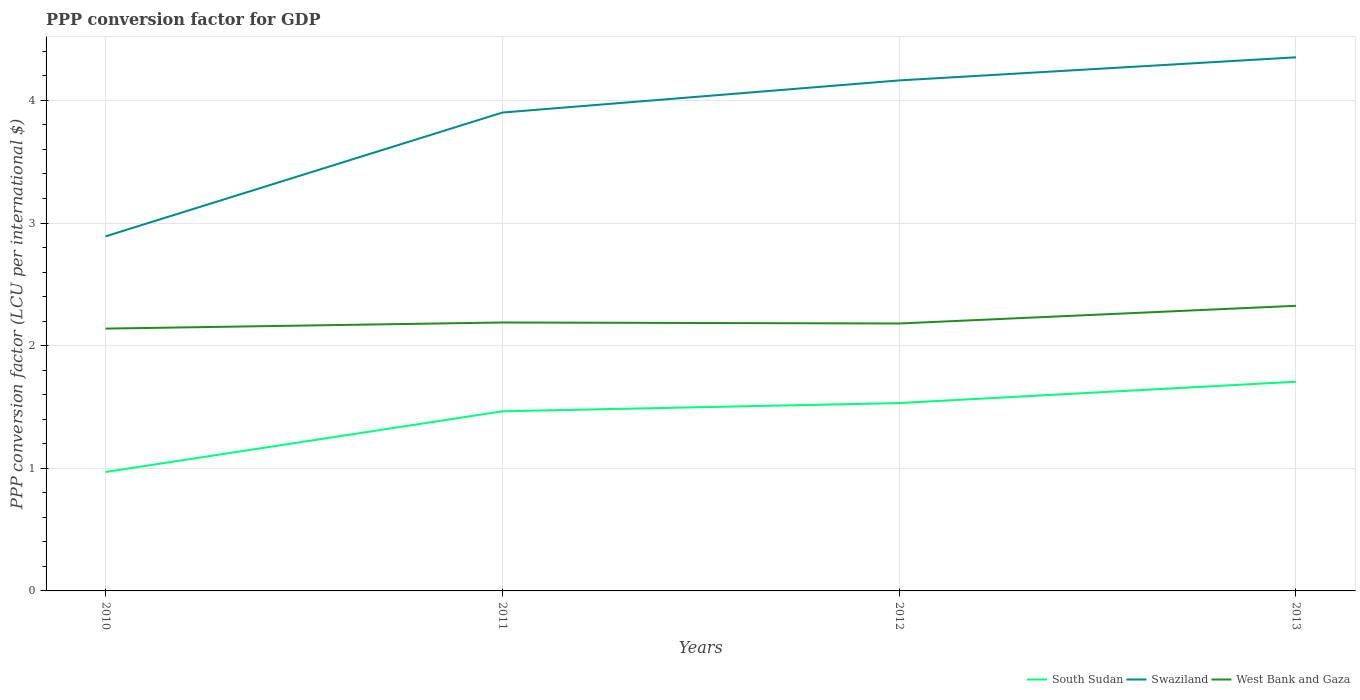How many different coloured lines are there?
Offer a very short reply. 3. Does the line corresponding to Swaziland intersect with the line corresponding to West Bank and Gaza?
Your answer should be very brief. No. Is the number of lines equal to the number of legend labels?
Provide a short and direct response. Yes. Across all years, what is the maximum PPP conversion factor for GDP in Swaziland?
Keep it short and to the point. 2.89. In which year was the PPP conversion factor for GDP in West Bank and Gaza maximum?
Your answer should be compact. 2010. What is the total PPP conversion factor for GDP in Swaziland in the graph?
Your response must be concise. -1.46. What is the difference between the highest and the second highest PPP conversion factor for GDP in South Sudan?
Ensure brevity in your answer.  0.74. Is the PPP conversion factor for GDP in West Bank and Gaza strictly greater than the PPP conversion factor for GDP in Swaziland over the years?
Make the answer very short. Yes. What is the difference between two consecutive major ticks on the Y-axis?
Ensure brevity in your answer.  1. Are the values on the major ticks of Y-axis written in scientific E-notation?
Offer a very short reply. No. Where does the legend appear in the graph?
Provide a short and direct response. Bottom right. How many legend labels are there?
Make the answer very short. 3. What is the title of the graph?
Make the answer very short. PPP conversion factor for GDP. Does "Micronesia" appear as one of the legend labels in the graph?
Offer a very short reply. No. What is the label or title of the Y-axis?
Keep it short and to the point. PPP conversion factor (LCU per international $). What is the PPP conversion factor (LCU per international $) of South Sudan in 2010?
Your answer should be compact. 0.97. What is the PPP conversion factor (LCU per international $) in Swaziland in 2010?
Offer a very short reply. 2.89. What is the PPP conversion factor (LCU per international $) of West Bank and Gaza in 2010?
Your response must be concise. 2.14. What is the PPP conversion factor (LCU per international $) of South Sudan in 2011?
Provide a succinct answer. 1.46. What is the PPP conversion factor (LCU per international $) of Swaziland in 2011?
Ensure brevity in your answer.  3.9. What is the PPP conversion factor (LCU per international $) of West Bank and Gaza in 2011?
Keep it short and to the point. 2.19. What is the PPP conversion factor (LCU per international $) of South Sudan in 2012?
Your response must be concise. 1.53. What is the PPP conversion factor (LCU per international $) in Swaziland in 2012?
Keep it short and to the point. 4.16. What is the PPP conversion factor (LCU per international $) in West Bank and Gaza in 2012?
Ensure brevity in your answer.  2.18. What is the PPP conversion factor (LCU per international $) of South Sudan in 2013?
Offer a very short reply. 1.71. What is the PPP conversion factor (LCU per international $) of Swaziland in 2013?
Keep it short and to the point. 4.35. What is the PPP conversion factor (LCU per international $) of West Bank and Gaza in 2013?
Your answer should be very brief. 2.32. Across all years, what is the maximum PPP conversion factor (LCU per international $) of South Sudan?
Offer a very short reply. 1.71. Across all years, what is the maximum PPP conversion factor (LCU per international $) in Swaziland?
Make the answer very short. 4.35. Across all years, what is the maximum PPP conversion factor (LCU per international $) of West Bank and Gaza?
Your answer should be compact. 2.32. Across all years, what is the minimum PPP conversion factor (LCU per international $) in South Sudan?
Offer a very short reply. 0.97. Across all years, what is the minimum PPP conversion factor (LCU per international $) of Swaziland?
Give a very brief answer. 2.89. Across all years, what is the minimum PPP conversion factor (LCU per international $) in West Bank and Gaza?
Offer a terse response. 2.14. What is the total PPP conversion factor (LCU per international $) in South Sudan in the graph?
Your answer should be very brief. 5.67. What is the total PPP conversion factor (LCU per international $) of Swaziland in the graph?
Offer a very short reply. 15.31. What is the total PPP conversion factor (LCU per international $) of West Bank and Gaza in the graph?
Provide a short and direct response. 8.83. What is the difference between the PPP conversion factor (LCU per international $) in South Sudan in 2010 and that in 2011?
Your answer should be very brief. -0.49. What is the difference between the PPP conversion factor (LCU per international $) in Swaziland in 2010 and that in 2011?
Offer a very short reply. -1.01. What is the difference between the PPP conversion factor (LCU per international $) in South Sudan in 2010 and that in 2012?
Your response must be concise. -0.56. What is the difference between the PPP conversion factor (LCU per international $) in Swaziland in 2010 and that in 2012?
Your answer should be very brief. -1.27. What is the difference between the PPP conversion factor (LCU per international $) of West Bank and Gaza in 2010 and that in 2012?
Make the answer very short. -0.04. What is the difference between the PPP conversion factor (LCU per international $) in South Sudan in 2010 and that in 2013?
Your answer should be compact. -0.74. What is the difference between the PPP conversion factor (LCU per international $) in Swaziland in 2010 and that in 2013?
Provide a succinct answer. -1.46. What is the difference between the PPP conversion factor (LCU per international $) of West Bank and Gaza in 2010 and that in 2013?
Offer a very short reply. -0.19. What is the difference between the PPP conversion factor (LCU per international $) in South Sudan in 2011 and that in 2012?
Provide a short and direct response. -0.07. What is the difference between the PPP conversion factor (LCU per international $) in Swaziland in 2011 and that in 2012?
Your answer should be compact. -0.26. What is the difference between the PPP conversion factor (LCU per international $) in West Bank and Gaza in 2011 and that in 2012?
Provide a succinct answer. 0.01. What is the difference between the PPP conversion factor (LCU per international $) of South Sudan in 2011 and that in 2013?
Provide a succinct answer. -0.24. What is the difference between the PPP conversion factor (LCU per international $) in Swaziland in 2011 and that in 2013?
Offer a very short reply. -0.45. What is the difference between the PPP conversion factor (LCU per international $) in West Bank and Gaza in 2011 and that in 2013?
Your answer should be very brief. -0.14. What is the difference between the PPP conversion factor (LCU per international $) of South Sudan in 2012 and that in 2013?
Your answer should be very brief. -0.17. What is the difference between the PPP conversion factor (LCU per international $) in Swaziland in 2012 and that in 2013?
Make the answer very short. -0.19. What is the difference between the PPP conversion factor (LCU per international $) in West Bank and Gaza in 2012 and that in 2013?
Your answer should be very brief. -0.14. What is the difference between the PPP conversion factor (LCU per international $) of South Sudan in 2010 and the PPP conversion factor (LCU per international $) of Swaziland in 2011?
Offer a terse response. -2.93. What is the difference between the PPP conversion factor (LCU per international $) of South Sudan in 2010 and the PPP conversion factor (LCU per international $) of West Bank and Gaza in 2011?
Provide a succinct answer. -1.22. What is the difference between the PPP conversion factor (LCU per international $) of Swaziland in 2010 and the PPP conversion factor (LCU per international $) of West Bank and Gaza in 2011?
Your answer should be compact. 0.7. What is the difference between the PPP conversion factor (LCU per international $) in South Sudan in 2010 and the PPP conversion factor (LCU per international $) in Swaziland in 2012?
Keep it short and to the point. -3.19. What is the difference between the PPP conversion factor (LCU per international $) of South Sudan in 2010 and the PPP conversion factor (LCU per international $) of West Bank and Gaza in 2012?
Offer a very short reply. -1.21. What is the difference between the PPP conversion factor (LCU per international $) in Swaziland in 2010 and the PPP conversion factor (LCU per international $) in West Bank and Gaza in 2012?
Provide a short and direct response. 0.71. What is the difference between the PPP conversion factor (LCU per international $) in South Sudan in 2010 and the PPP conversion factor (LCU per international $) in Swaziland in 2013?
Keep it short and to the point. -3.38. What is the difference between the PPP conversion factor (LCU per international $) in South Sudan in 2010 and the PPP conversion factor (LCU per international $) in West Bank and Gaza in 2013?
Offer a very short reply. -1.36. What is the difference between the PPP conversion factor (LCU per international $) in Swaziland in 2010 and the PPP conversion factor (LCU per international $) in West Bank and Gaza in 2013?
Provide a succinct answer. 0.57. What is the difference between the PPP conversion factor (LCU per international $) of South Sudan in 2011 and the PPP conversion factor (LCU per international $) of Swaziland in 2012?
Your answer should be compact. -2.7. What is the difference between the PPP conversion factor (LCU per international $) in South Sudan in 2011 and the PPP conversion factor (LCU per international $) in West Bank and Gaza in 2012?
Make the answer very short. -0.72. What is the difference between the PPP conversion factor (LCU per international $) in Swaziland in 2011 and the PPP conversion factor (LCU per international $) in West Bank and Gaza in 2012?
Give a very brief answer. 1.72. What is the difference between the PPP conversion factor (LCU per international $) in South Sudan in 2011 and the PPP conversion factor (LCU per international $) in Swaziland in 2013?
Ensure brevity in your answer.  -2.89. What is the difference between the PPP conversion factor (LCU per international $) in South Sudan in 2011 and the PPP conversion factor (LCU per international $) in West Bank and Gaza in 2013?
Offer a terse response. -0.86. What is the difference between the PPP conversion factor (LCU per international $) in Swaziland in 2011 and the PPP conversion factor (LCU per international $) in West Bank and Gaza in 2013?
Your answer should be compact. 1.58. What is the difference between the PPP conversion factor (LCU per international $) in South Sudan in 2012 and the PPP conversion factor (LCU per international $) in Swaziland in 2013?
Ensure brevity in your answer.  -2.82. What is the difference between the PPP conversion factor (LCU per international $) in South Sudan in 2012 and the PPP conversion factor (LCU per international $) in West Bank and Gaza in 2013?
Ensure brevity in your answer.  -0.79. What is the difference between the PPP conversion factor (LCU per international $) in Swaziland in 2012 and the PPP conversion factor (LCU per international $) in West Bank and Gaza in 2013?
Your response must be concise. 1.84. What is the average PPP conversion factor (LCU per international $) of South Sudan per year?
Make the answer very short. 1.42. What is the average PPP conversion factor (LCU per international $) of Swaziland per year?
Provide a succinct answer. 3.83. What is the average PPP conversion factor (LCU per international $) in West Bank and Gaza per year?
Give a very brief answer. 2.21. In the year 2010, what is the difference between the PPP conversion factor (LCU per international $) in South Sudan and PPP conversion factor (LCU per international $) in Swaziland?
Your response must be concise. -1.92. In the year 2010, what is the difference between the PPP conversion factor (LCU per international $) in South Sudan and PPP conversion factor (LCU per international $) in West Bank and Gaza?
Offer a terse response. -1.17. In the year 2010, what is the difference between the PPP conversion factor (LCU per international $) in Swaziland and PPP conversion factor (LCU per international $) in West Bank and Gaza?
Make the answer very short. 0.75. In the year 2011, what is the difference between the PPP conversion factor (LCU per international $) in South Sudan and PPP conversion factor (LCU per international $) in Swaziland?
Give a very brief answer. -2.44. In the year 2011, what is the difference between the PPP conversion factor (LCU per international $) in South Sudan and PPP conversion factor (LCU per international $) in West Bank and Gaza?
Your answer should be very brief. -0.72. In the year 2011, what is the difference between the PPP conversion factor (LCU per international $) in Swaziland and PPP conversion factor (LCU per international $) in West Bank and Gaza?
Your answer should be compact. 1.71. In the year 2012, what is the difference between the PPP conversion factor (LCU per international $) of South Sudan and PPP conversion factor (LCU per international $) of Swaziland?
Provide a succinct answer. -2.63. In the year 2012, what is the difference between the PPP conversion factor (LCU per international $) in South Sudan and PPP conversion factor (LCU per international $) in West Bank and Gaza?
Ensure brevity in your answer.  -0.65. In the year 2012, what is the difference between the PPP conversion factor (LCU per international $) of Swaziland and PPP conversion factor (LCU per international $) of West Bank and Gaza?
Provide a succinct answer. 1.98. In the year 2013, what is the difference between the PPP conversion factor (LCU per international $) of South Sudan and PPP conversion factor (LCU per international $) of Swaziland?
Offer a very short reply. -2.65. In the year 2013, what is the difference between the PPP conversion factor (LCU per international $) of South Sudan and PPP conversion factor (LCU per international $) of West Bank and Gaza?
Your answer should be compact. -0.62. In the year 2013, what is the difference between the PPP conversion factor (LCU per international $) of Swaziland and PPP conversion factor (LCU per international $) of West Bank and Gaza?
Provide a succinct answer. 2.03. What is the ratio of the PPP conversion factor (LCU per international $) of South Sudan in 2010 to that in 2011?
Your answer should be compact. 0.66. What is the ratio of the PPP conversion factor (LCU per international $) in Swaziland in 2010 to that in 2011?
Provide a short and direct response. 0.74. What is the ratio of the PPP conversion factor (LCU per international $) of West Bank and Gaza in 2010 to that in 2011?
Provide a succinct answer. 0.98. What is the ratio of the PPP conversion factor (LCU per international $) of South Sudan in 2010 to that in 2012?
Your answer should be compact. 0.63. What is the ratio of the PPP conversion factor (LCU per international $) of Swaziland in 2010 to that in 2012?
Offer a terse response. 0.69. What is the ratio of the PPP conversion factor (LCU per international $) in West Bank and Gaza in 2010 to that in 2012?
Provide a short and direct response. 0.98. What is the ratio of the PPP conversion factor (LCU per international $) of South Sudan in 2010 to that in 2013?
Your answer should be very brief. 0.57. What is the ratio of the PPP conversion factor (LCU per international $) of Swaziland in 2010 to that in 2013?
Ensure brevity in your answer.  0.66. What is the ratio of the PPP conversion factor (LCU per international $) of West Bank and Gaza in 2010 to that in 2013?
Offer a very short reply. 0.92. What is the ratio of the PPP conversion factor (LCU per international $) in South Sudan in 2011 to that in 2012?
Provide a succinct answer. 0.96. What is the ratio of the PPP conversion factor (LCU per international $) in Swaziland in 2011 to that in 2012?
Your answer should be compact. 0.94. What is the ratio of the PPP conversion factor (LCU per international $) in West Bank and Gaza in 2011 to that in 2012?
Offer a very short reply. 1. What is the ratio of the PPP conversion factor (LCU per international $) of South Sudan in 2011 to that in 2013?
Ensure brevity in your answer.  0.86. What is the ratio of the PPP conversion factor (LCU per international $) of Swaziland in 2011 to that in 2013?
Provide a succinct answer. 0.9. What is the ratio of the PPP conversion factor (LCU per international $) in West Bank and Gaza in 2011 to that in 2013?
Your answer should be compact. 0.94. What is the ratio of the PPP conversion factor (LCU per international $) in South Sudan in 2012 to that in 2013?
Keep it short and to the point. 0.9. What is the ratio of the PPP conversion factor (LCU per international $) in Swaziland in 2012 to that in 2013?
Provide a short and direct response. 0.96. What is the ratio of the PPP conversion factor (LCU per international $) of West Bank and Gaza in 2012 to that in 2013?
Offer a very short reply. 0.94. What is the difference between the highest and the second highest PPP conversion factor (LCU per international $) of South Sudan?
Ensure brevity in your answer.  0.17. What is the difference between the highest and the second highest PPP conversion factor (LCU per international $) in Swaziland?
Your response must be concise. 0.19. What is the difference between the highest and the second highest PPP conversion factor (LCU per international $) in West Bank and Gaza?
Provide a short and direct response. 0.14. What is the difference between the highest and the lowest PPP conversion factor (LCU per international $) in South Sudan?
Make the answer very short. 0.74. What is the difference between the highest and the lowest PPP conversion factor (LCU per international $) in Swaziland?
Offer a terse response. 1.46. What is the difference between the highest and the lowest PPP conversion factor (LCU per international $) in West Bank and Gaza?
Your answer should be very brief. 0.19. 